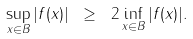<formula> <loc_0><loc_0><loc_500><loc_500>\sup _ { x \in B } | f ( x ) | \ \geq \ 2 \inf _ { x \in B } | f ( x ) | .</formula> 